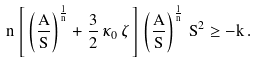<formula> <loc_0><loc_0><loc_500><loc_500>n \left [ \, \left ( \frac { A } { S } \right ) ^ { \frac { 1 } { n } } + \frac { 3 } { 2 } \, \kappa _ { 0 } \, \zeta \, \right ] \left ( \frac { A } { S } \right ) ^ { \frac { 1 } { n } } \, S ^ { 2 } \geq - k \, .</formula> 